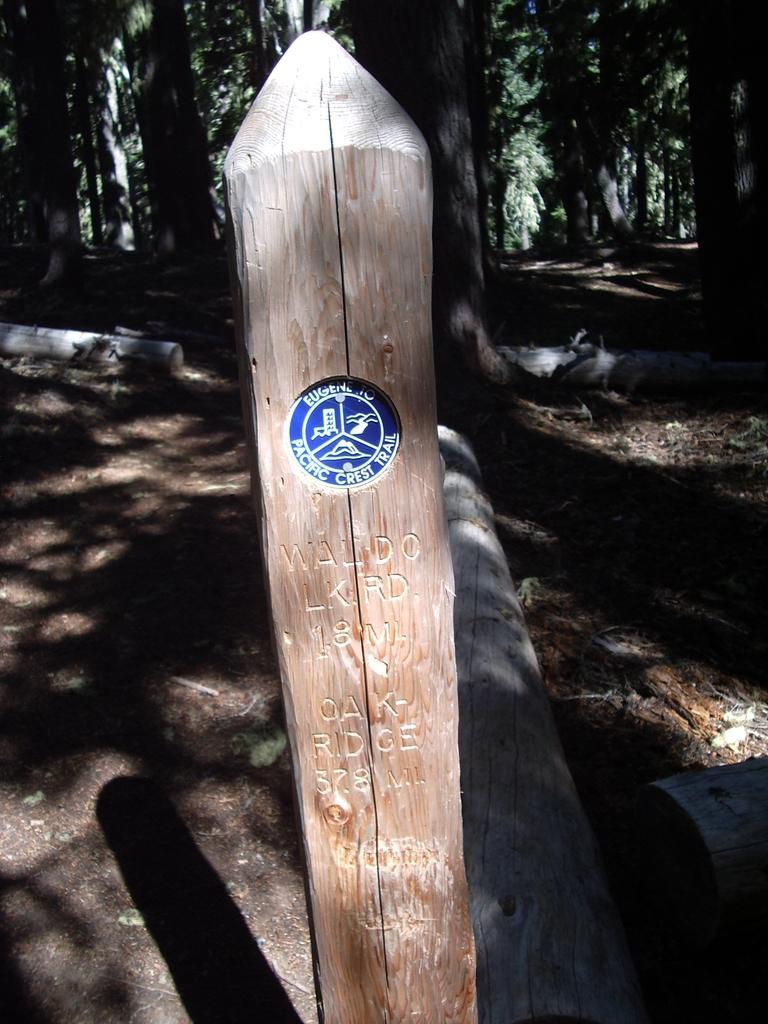How would you summarize this image in a sentence or two? In this image on the foreground there is a wooden pole. On it something is written. In the background there are trees. 